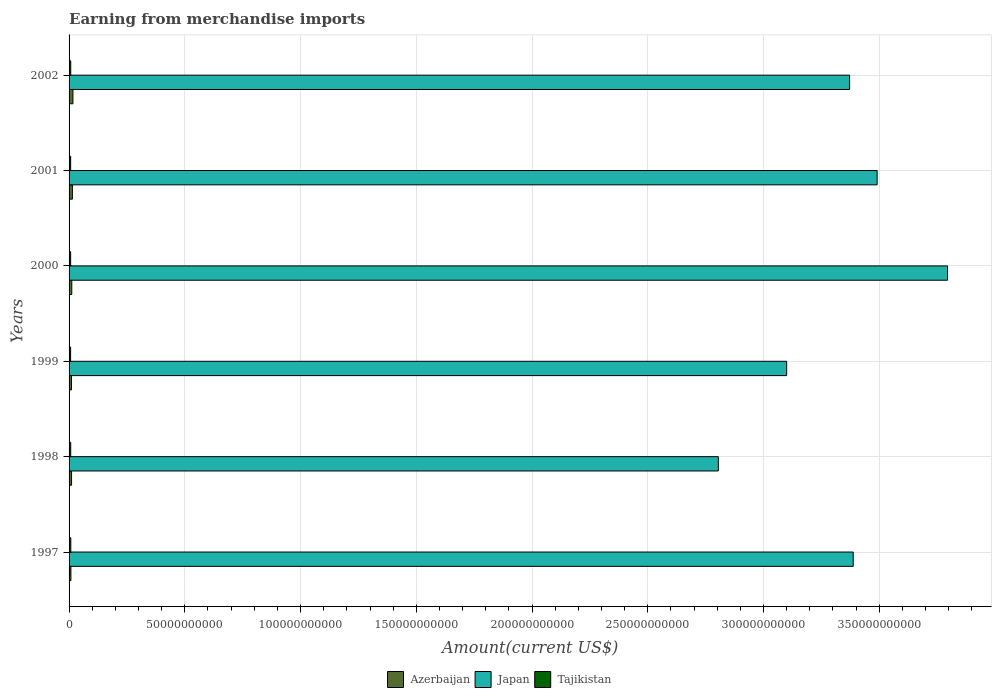How many bars are there on the 6th tick from the top?
Your answer should be very brief. 3. What is the amount earned from merchandise imports in Japan in 2001?
Offer a very short reply. 3.49e+11. Across all years, what is the maximum amount earned from merchandise imports in Azerbaijan?
Give a very brief answer. 1.67e+09. Across all years, what is the minimum amount earned from merchandise imports in Tajikistan?
Provide a short and direct response. 6.63e+08. In which year was the amount earned from merchandise imports in Japan maximum?
Provide a short and direct response. 2000. What is the total amount earned from merchandise imports in Tajikistan in the graph?
Provide a succinct answer. 4.21e+09. What is the difference between the amount earned from merchandise imports in Tajikistan in 1998 and that in 2002?
Offer a very short reply. -1.10e+07. What is the difference between the amount earned from merchandise imports in Tajikistan in 2000 and the amount earned from merchandise imports in Japan in 2001?
Your response must be concise. -3.48e+11. What is the average amount earned from merchandise imports in Azerbaijan per year?
Provide a succinct answer. 1.20e+09. In the year 2002, what is the difference between the amount earned from merchandise imports in Japan and amount earned from merchandise imports in Azerbaijan?
Your answer should be compact. 3.36e+11. In how many years, is the amount earned from merchandise imports in Tajikistan greater than 270000000000 US$?
Ensure brevity in your answer.  0. What is the ratio of the amount earned from merchandise imports in Azerbaijan in 1999 to that in 2001?
Ensure brevity in your answer.  0.72. Is the amount earned from merchandise imports in Japan in 1998 less than that in 2001?
Provide a succinct answer. Yes. Is the difference between the amount earned from merchandise imports in Japan in 1999 and 2000 greater than the difference between the amount earned from merchandise imports in Azerbaijan in 1999 and 2000?
Ensure brevity in your answer.  No. What is the difference between the highest and the second highest amount earned from merchandise imports in Tajikistan?
Ensure brevity in your answer.  2.90e+07. What is the difference between the highest and the lowest amount earned from merchandise imports in Azerbaijan?
Provide a succinct answer. 8.72e+08. In how many years, is the amount earned from merchandise imports in Azerbaijan greater than the average amount earned from merchandise imports in Azerbaijan taken over all years?
Give a very brief answer. 2. What does the 3rd bar from the top in 1997 represents?
Make the answer very short. Azerbaijan. What does the 1st bar from the bottom in 1999 represents?
Offer a very short reply. Azerbaijan. Is it the case that in every year, the sum of the amount earned from merchandise imports in Japan and amount earned from merchandise imports in Azerbaijan is greater than the amount earned from merchandise imports in Tajikistan?
Your answer should be compact. Yes. How many years are there in the graph?
Keep it short and to the point. 6. Are the values on the major ticks of X-axis written in scientific E-notation?
Your response must be concise. No. Does the graph contain any zero values?
Your answer should be compact. No. Does the graph contain grids?
Offer a very short reply. Yes. How are the legend labels stacked?
Make the answer very short. Horizontal. What is the title of the graph?
Your answer should be compact. Earning from merchandise imports. What is the label or title of the X-axis?
Ensure brevity in your answer.  Amount(current US$). What is the label or title of the Y-axis?
Provide a short and direct response. Years. What is the Amount(current US$) of Azerbaijan in 1997?
Your response must be concise. 7.94e+08. What is the Amount(current US$) in Japan in 1997?
Your answer should be compact. 3.39e+11. What is the Amount(current US$) of Tajikistan in 1997?
Ensure brevity in your answer.  7.50e+08. What is the Amount(current US$) in Azerbaijan in 1998?
Offer a very short reply. 1.08e+09. What is the Amount(current US$) in Japan in 1998?
Offer a very short reply. 2.80e+11. What is the Amount(current US$) in Tajikistan in 1998?
Provide a short and direct response. 7.10e+08. What is the Amount(current US$) of Azerbaijan in 1999?
Offer a very short reply. 1.04e+09. What is the Amount(current US$) of Japan in 1999?
Provide a short and direct response. 3.10e+11. What is the Amount(current US$) of Tajikistan in 1999?
Keep it short and to the point. 6.63e+08. What is the Amount(current US$) of Azerbaijan in 2000?
Give a very brief answer. 1.17e+09. What is the Amount(current US$) in Japan in 2000?
Your answer should be very brief. 3.80e+11. What is the Amount(current US$) in Tajikistan in 2000?
Your response must be concise. 6.75e+08. What is the Amount(current US$) in Azerbaijan in 2001?
Provide a short and direct response. 1.43e+09. What is the Amount(current US$) in Japan in 2001?
Provide a succinct answer. 3.49e+11. What is the Amount(current US$) in Tajikistan in 2001?
Ensure brevity in your answer.  6.88e+08. What is the Amount(current US$) in Azerbaijan in 2002?
Offer a very short reply. 1.67e+09. What is the Amount(current US$) in Japan in 2002?
Offer a terse response. 3.37e+11. What is the Amount(current US$) in Tajikistan in 2002?
Give a very brief answer. 7.21e+08. Across all years, what is the maximum Amount(current US$) in Azerbaijan?
Give a very brief answer. 1.67e+09. Across all years, what is the maximum Amount(current US$) in Japan?
Offer a very short reply. 3.80e+11. Across all years, what is the maximum Amount(current US$) in Tajikistan?
Offer a terse response. 7.50e+08. Across all years, what is the minimum Amount(current US$) in Azerbaijan?
Ensure brevity in your answer.  7.94e+08. Across all years, what is the minimum Amount(current US$) in Japan?
Your answer should be compact. 2.80e+11. Across all years, what is the minimum Amount(current US$) of Tajikistan?
Ensure brevity in your answer.  6.63e+08. What is the total Amount(current US$) in Azerbaijan in the graph?
Your response must be concise. 7.17e+09. What is the total Amount(current US$) of Japan in the graph?
Your answer should be very brief. 2.00e+12. What is the total Amount(current US$) of Tajikistan in the graph?
Offer a terse response. 4.21e+09. What is the difference between the Amount(current US$) in Azerbaijan in 1997 and that in 1998?
Make the answer very short. -2.82e+08. What is the difference between the Amount(current US$) in Japan in 1997 and that in 1998?
Offer a very short reply. 5.83e+1. What is the difference between the Amount(current US$) of Tajikistan in 1997 and that in 1998?
Your answer should be very brief. 4.00e+07. What is the difference between the Amount(current US$) in Azerbaijan in 1997 and that in 1999?
Keep it short and to the point. -2.42e+08. What is the difference between the Amount(current US$) of Japan in 1997 and that in 1999?
Your answer should be compact. 2.88e+1. What is the difference between the Amount(current US$) of Tajikistan in 1997 and that in 1999?
Make the answer very short. 8.70e+07. What is the difference between the Amount(current US$) in Azerbaijan in 1997 and that in 2000?
Provide a short and direct response. -3.78e+08. What is the difference between the Amount(current US$) in Japan in 1997 and that in 2000?
Your answer should be compact. -4.08e+1. What is the difference between the Amount(current US$) of Tajikistan in 1997 and that in 2000?
Your answer should be compact. 7.50e+07. What is the difference between the Amount(current US$) in Azerbaijan in 1997 and that in 2001?
Your response must be concise. -6.37e+08. What is the difference between the Amount(current US$) in Japan in 1997 and that in 2001?
Offer a very short reply. -1.03e+1. What is the difference between the Amount(current US$) in Tajikistan in 1997 and that in 2001?
Your answer should be very brief. 6.20e+07. What is the difference between the Amount(current US$) of Azerbaijan in 1997 and that in 2002?
Give a very brief answer. -8.72e+08. What is the difference between the Amount(current US$) in Japan in 1997 and that in 2002?
Provide a short and direct response. 1.56e+09. What is the difference between the Amount(current US$) of Tajikistan in 1997 and that in 2002?
Provide a succinct answer. 2.90e+07. What is the difference between the Amount(current US$) of Azerbaijan in 1998 and that in 1999?
Offer a very short reply. 4.00e+07. What is the difference between the Amount(current US$) of Japan in 1998 and that in 1999?
Provide a short and direct response. -2.95e+1. What is the difference between the Amount(current US$) in Tajikistan in 1998 and that in 1999?
Give a very brief answer. 4.70e+07. What is the difference between the Amount(current US$) in Azerbaijan in 1998 and that in 2000?
Offer a terse response. -9.60e+07. What is the difference between the Amount(current US$) in Japan in 1998 and that in 2000?
Offer a very short reply. -9.90e+1. What is the difference between the Amount(current US$) of Tajikistan in 1998 and that in 2000?
Provide a succinct answer. 3.50e+07. What is the difference between the Amount(current US$) in Azerbaijan in 1998 and that in 2001?
Make the answer very short. -3.55e+08. What is the difference between the Amount(current US$) of Japan in 1998 and that in 2001?
Your response must be concise. -6.86e+1. What is the difference between the Amount(current US$) of Tajikistan in 1998 and that in 2001?
Your answer should be very brief. 2.20e+07. What is the difference between the Amount(current US$) in Azerbaijan in 1998 and that in 2002?
Offer a terse response. -5.90e+08. What is the difference between the Amount(current US$) in Japan in 1998 and that in 2002?
Provide a succinct answer. -5.67e+1. What is the difference between the Amount(current US$) in Tajikistan in 1998 and that in 2002?
Provide a succinct answer. -1.10e+07. What is the difference between the Amount(current US$) of Azerbaijan in 1999 and that in 2000?
Provide a succinct answer. -1.36e+08. What is the difference between the Amount(current US$) in Japan in 1999 and that in 2000?
Your response must be concise. -6.95e+1. What is the difference between the Amount(current US$) of Tajikistan in 1999 and that in 2000?
Provide a short and direct response. -1.20e+07. What is the difference between the Amount(current US$) of Azerbaijan in 1999 and that in 2001?
Offer a very short reply. -3.95e+08. What is the difference between the Amount(current US$) in Japan in 1999 and that in 2001?
Keep it short and to the point. -3.91e+1. What is the difference between the Amount(current US$) in Tajikistan in 1999 and that in 2001?
Give a very brief answer. -2.50e+07. What is the difference between the Amount(current US$) of Azerbaijan in 1999 and that in 2002?
Your answer should be compact. -6.30e+08. What is the difference between the Amount(current US$) of Japan in 1999 and that in 2002?
Keep it short and to the point. -2.72e+1. What is the difference between the Amount(current US$) in Tajikistan in 1999 and that in 2002?
Your answer should be very brief. -5.80e+07. What is the difference between the Amount(current US$) in Azerbaijan in 2000 and that in 2001?
Provide a short and direct response. -2.59e+08. What is the difference between the Amount(current US$) of Japan in 2000 and that in 2001?
Provide a succinct answer. 3.04e+1. What is the difference between the Amount(current US$) of Tajikistan in 2000 and that in 2001?
Provide a short and direct response. -1.30e+07. What is the difference between the Amount(current US$) in Azerbaijan in 2000 and that in 2002?
Make the answer very short. -4.94e+08. What is the difference between the Amount(current US$) in Japan in 2000 and that in 2002?
Keep it short and to the point. 4.23e+1. What is the difference between the Amount(current US$) of Tajikistan in 2000 and that in 2002?
Ensure brevity in your answer.  -4.60e+07. What is the difference between the Amount(current US$) in Azerbaijan in 2001 and that in 2002?
Your response must be concise. -2.34e+08. What is the difference between the Amount(current US$) in Japan in 2001 and that in 2002?
Ensure brevity in your answer.  1.19e+1. What is the difference between the Amount(current US$) in Tajikistan in 2001 and that in 2002?
Keep it short and to the point. -3.30e+07. What is the difference between the Amount(current US$) of Azerbaijan in 1997 and the Amount(current US$) of Japan in 1998?
Make the answer very short. -2.80e+11. What is the difference between the Amount(current US$) of Azerbaijan in 1997 and the Amount(current US$) of Tajikistan in 1998?
Keep it short and to the point. 8.40e+07. What is the difference between the Amount(current US$) of Japan in 1997 and the Amount(current US$) of Tajikistan in 1998?
Provide a short and direct response. 3.38e+11. What is the difference between the Amount(current US$) of Azerbaijan in 1997 and the Amount(current US$) of Japan in 1999?
Your response must be concise. -3.09e+11. What is the difference between the Amount(current US$) in Azerbaijan in 1997 and the Amount(current US$) in Tajikistan in 1999?
Keep it short and to the point. 1.31e+08. What is the difference between the Amount(current US$) of Japan in 1997 and the Amount(current US$) of Tajikistan in 1999?
Keep it short and to the point. 3.38e+11. What is the difference between the Amount(current US$) in Azerbaijan in 1997 and the Amount(current US$) in Japan in 2000?
Offer a very short reply. -3.79e+11. What is the difference between the Amount(current US$) of Azerbaijan in 1997 and the Amount(current US$) of Tajikistan in 2000?
Offer a terse response. 1.19e+08. What is the difference between the Amount(current US$) of Japan in 1997 and the Amount(current US$) of Tajikistan in 2000?
Offer a terse response. 3.38e+11. What is the difference between the Amount(current US$) in Azerbaijan in 1997 and the Amount(current US$) in Japan in 2001?
Provide a succinct answer. -3.48e+11. What is the difference between the Amount(current US$) of Azerbaijan in 1997 and the Amount(current US$) of Tajikistan in 2001?
Provide a succinct answer. 1.06e+08. What is the difference between the Amount(current US$) in Japan in 1997 and the Amount(current US$) in Tajikistan in 2001?
Offer a very short reply. 3.38e+11. What is the difference between the Amount(current US$) in Azerbaijan in 1997 and the Amount(current US$) in Japan in 2002?
Ensure brevity in your answer.  -3.36e+11. What is the difference between the Amount(current US$) in Azerbaijan in 1997 and the Amount(current US$) in Tajikistan in 2002?
Your response must be concise. 7.30e+07. What is the difference between the Amount(current US$) in Japan in 1997 and the Amount(current US$) in Tajikistan in 2002?
Provide a short and direct response. 3.38e+11. What is the difference between the Amount(current US$) in Azerbaijan in 1998 and the Amount(current US$) in Japan in 1999?
Provide a succinct answer. -3.09e+11. What is the difference between the Amount(current US$) in Azerbaijan in 1998 and the Amount(current US$) in Tajikistan in 1999?
Your answer should be compact. 4.13e+08. What is the difference between the Amount(current US$) of Japan in 1998 and the Amount(current US$) of Tajikistan in 1999?
Offer a very short reply. 2.80e+11. What is the difference between the Amount(current US$) in Azerbaijan in 1998 and the Amount(current US$) in Japan in 2000?
Provide a short and direct response. -3.78e+11. What is the difference between the Amount(current US$) of Azerbaijan in 1998 and the Amount(current US$) of Tajikistan in 2000?
Give a very brief answer. 4.01e+08. What is the difference between the Amount(current US$) in Japan in 1998 and the Amount(current US$) in Tajikistan in 2000?
Keep it short and to the point. 2.80e+11. What is the difference between the Amount(current US$) of Azerbaijan in 1998 and the Amount(current US$) of Japan in 2001?
Offer a terse response. -3.48e+11. What is the difference between the Amount(current US$) of Azerbaijan in 1998 and the Amount(current US$) of Tajikistan in 2001?
Ensure brevity in your answer.  3.88e+08. What is the difference between the Amount(current US$) of Japan in 1998 and the Amount(current US$) of Tajikistan in 2001?
Make the answer very short. 2.80e+11. What is the difference between the Amount(current US$) of Azerbaijan in 1998 and the Amount(current US$) of Japan in 2002?
Your answer should be compact. -3.36e+11. What is the difference between the Amount(current US$) in Azerbaijan in 1998 and the Amount(current US$) in Tajikistan in 2002?
Provide a succinct answer. 3.55e+08. What is the difference between the Amount(current US$) of Japan in 1998 and the Amount(current US$) of Tajikistan in 2002?
Provide a short and direct response. 2.80e+11. What is the difference between the Amount(current US$) in Azerbaijan in 1999 and the Amount(current US$) in Japan in 2000?
Your answer should be compact. -3.78e+11. What is the difference between the Amount(current US$) of Azerbaijan in 1999 and the Amount(current US$) of Tajikistan in 2000?
Offer a terse response. 3.61e+08. What is the difference between the Amount(current US$) of Japan in 1999 and the Amount(current US$) of Tajikistan in 2000?
Make the answer very short. 3.09e+11. What is the difference between the Amount(current US$) of Azerbaijan in 1999 and the Amount(current US$) of Japan in 2001?
Offer a terse response. -3.48e+11. What is the difference between the Amount(current US$) of Azerbaijan in 1999 and the Amount(current US$) of Tajikistan in 2001?
Offer a very short reply. 3.48e+08. What is the difference between the Amount(current US$) of Japan in 1999 and the Amount(current US$) of Tajikistan in 2001?
Make the answer very short. 3.09e+11. What is the difference between the Amount(current US$) of Azerbaijan in 1999 and the Amount(current US$) of Japan in 2002?
Your answer should be compact. -3.36e+11. What is the difference between the Amount(current US$) in Azerbaijan in 1999 and the Amount(current US$) in Tajikistan in 2002?
Your answer should be very brief. 3.15e+08. What is the difference between the Amount(current US$) of Japan in 1999 and the Amount(current US$) of Tajikistan in 2002?
Make the answer very short. 3.09e+11. What is the difference between the Amount(current US$) in Azerbaijan in 2000 and the Amount(current US$) in Japan in 2001?
Ensure brevity in your answer.  -3.48e+11. What is the difference between the Amount(current US$) in Azerbaijan in 2000 and the Amount(current US$) in Tajikistan in 2001?
Make the answer very short. 4.84e+08. What is the difference between the Amount(current US$) of Japan in 2000 and the Amount(current US$) of Tajikistan in 2001?
Give a very brief answer. 3.79e+11. What is the difference between the Amount(current US$) in Azerbaijan in 2000 and the Amount(current US$) in Japan in 2002?
Provide a short and direct response. -3.36e+11. What is the difference between the Amount(current US$) in Azerbaijan in 2000 and the Amount(current US$) in Tajikistan in 2002?
Your response must be concise. 4.51e+08. What is the difference between the Amount(current US$) in Japan in 2000 and the Amount(current US$) in Tajikistan in 2002?
Your answer should be compact. 3.79e+11. What is the difference between the Amount(current US$) in Azerbaijan in 2001 and the Amount(current US$) in Japan in 2002?
Ensure brevity in your answer.  -3.36e+11. What is the difference between the Amount(current US$) of Azerbaijan in 2001 and the Amount(current US$) of Tajikistan in 2002?
Make the answer very short. 7.10e+08. What is the difference between the Amount(current US$) of Japan in 2001 and the Amount(current US$) of Tajikistan in 2002?
Your response must be concise. 3.48e+11. What is the average Amount(current US$) in Azerbaijan per year?
Provide a succinct answer. 1.20e+09. What is the average Amount(current US$) in Japan per year?
Your response must be concise. 3.33e+11. What is the average Amount(current US$) of Tajikistan per year?
Make the answer very short. 7.01e+08. In the year 1997, what is the difference between the Amount(current US$) of Azerbaijan and Amount(current US$) of Japan?
Provide a short and direct response. -3.38e+11. In the year 1997, what is the difference between the Amount(current US$) of Azerbaijan and Amount(current US$) of Tajikistan?
Make the answer very short. 4.40e+07. In the year 1997, what is the difference between the Amount(current US$) in Japan and Amount(current US$) in Tajikistan?
Provide a short and direct response. 3.38e+11. In the year 1998, what is the difference between the Amount(current US$) of Azerbaijan and Amount(current US$) of Japan?
Your answer should be compact. -2.79e+11. In the year 1998, what is the difference between the Amount(current US$) in Azerbaijan and Amount(current US$) in Tajikistan?
Keep it short and to the point. 3.66e+08. In the year 1998, what is the difference between the Amount(current US$) in Japan and Amount(current US$) in Tajikistan?
Your answer should be very brief. 2.80e+11. In the year 1999, what is the difference between the Amount(current US$) of Azerbaijan and Amount(current US$) of Japan?
Provide a succinct answer. -3.09e+11. In the year 1999, what is the difference between the Amount(current US$) of Azerbaijan and Amount(current US$) of Tajikistan?
Give a very brief answer. 3.73e+08. In the year 1999, what is the difference between the Amount(current US$) of Japan and Amount(current US$) of Tajikistan?
Your answer should be compact. 3.09e+11. In the year 2000, what is the difference between the Amount(current US$) in Azerbaijan and Amount(current US$) in Japan?
Offer a terse response. -3.78e+11. In the year 2000, what is the difference between the Amount(current US$) in Azerbaijan and Amount(current US$) in Tajikistan?
Make the answer very short. 4.97e+08. In the year 2000, what is the difference between the Amount(current US$) of Japan and Amount(current US$) of Tajikistan?
Keep it short and to the point. 3.79e+11. In the year 2001, what is the difference between the Amount(current US$) in Azerbaijan and Amount(current US$) in Japan?
Your answer should be compact. -3.48e+11. In the year 2001, what is the difference between the Amount(current US$) in Azerbaijan and Amount(current US$) in Tajikistan?
Ensure brevity in your answer.  7.43e+08. In the year 2001, what is the difference between the Amount(current US$) of Japan and Amount(current US$) of Tajikistan?
Offer a very short reply. 3.48e+11. In the year 2002, what is the difference between the Amount(current US$) of Azerbaijan and Amount(current US$) of Japan?
Your answer should be very brief. -3.36e+11. In the year 2002, what is the difference between the Amount(current US$) in Azerbaijan and Amount(current US$) in Tajikistan?
Give a very brief answer. 9.44e+08. In the year 2002, what is the difference between the Amount(current US$) of Japan and Amount(current US$) of Tajikistan?
Give a very brief answer. 3.36e+11. What is the ratio of the Amount(current US$) in Azerbaijan in 1997 to that in 1998?
Offer a very short reply. 0.74. What is the ratio of the Amount(current US$) in Japan in 1997 to that in 1998?
Give a very brief answer. 1.21. What is the ratio of the Amount(current US$) of Tajikistan in 1997 to that in 1998?
Offer a very short reply. 1.06. What is the ratio of the Amount(current US$) of Azerbaijan in 1997 to that in 1999?
Offer a terse response. 0.77. What is the ratio of the Amount(current US$) in Japan in 1997 to that in 1999?
Your answer should be compact. 1.09. What is the ratio of the Amount(current US$) in Tajikistan in 1997 to that in 1999?
Offer a terse response. 1.13. What is the ratio of the Amount(current US$) in Azerbaijan in 1997 to that in 2000?
Ensure brevity in your answer.  0.68. What is the ratio of the Amount(current US$) in Japan in 1997 to that in 2000?
Give a very brief answer. 0.89. What is the ratio of the Amount(current US$) in Tajikistan in 1997 to that in 2000?
Keep it short and to the point. 1.11. What is the ratio of the Amount(current US$) in Azerbaijan in 1997 to that in 2001?
Offer a terse response. 0.55. What is the ratio of the Amount(current US$) of Japan in 1997 to that in 2001?
Your answer should be very brief. 0.97. What is the ratio of the Amount(current US$) in Tajikistan in 1997 to that in 2001?
Offer a terse response. 1.09. What is the ratio of the Amount(current US$) of Azerbaijan in 1997 to that in 2002?
Your response must be concise. 0.48. What is the ratio of the Amount(current US$) of Japan in 1997 to that in 2002?
Your response must be concise. 1. What is the ratio of the Amount(current US$) of Tajikistan in 1997 to that in 2002?
Your answer should be very brief. 1.04. What is the ratio of the Amount(current US$) in Azerbaijan in 1998 to that in 1999?
Offer a terse response. 1.04. What is the ratio of the Amount(current US$) in Japan in 1998 to that in 1999?
Give a very brief answer. 0.9. What is the ratio of the Amount(current US$) in Tajikistan in 1998 to that in 1999?
Provide a short and direct response. 1.07. What is the ratio of the Amount(current US$) in Azerbaijan in 1998 to that in 2000?
Provide a succinct answer. 0.92. What is the ratio of the Amount(current US$) of Japan in 1998 to that in 2000?
Provide a short and direct response. 0.74. What is the ratio of the Amount(current US$) of Tajikistan in 1998 to that in 2000?
Ensure brevity in your answer.  1.05. What is the ratio of the Amount(current US$) in Azerbaijan in 1998 to that in 2001?
Keep it short and to the point. 0.75. What is the ratio of the Amount(current US$) of Japan in 1998 to that in 2001?
Keep it short and to the point. 0.8. What is the ratio of the Amount(current US$) in Tajikistan in 1998 to that in 2001?
Give a very brief answer. 1.03. What is the ratio of the Amount(current US$) in Azerbaijan in 1998 to that in 2002?
Your answer should be very brief. 0.65. What is the ratio of the Amount(current US$) of Japan in 1998 to that in 2002?
Keep it short and to the point. 0.83. What is the ratio of the Amount(current US$) in Tajikistan in 1998 to that in 2002?
Give a very brief answer. 0.98. What is the ratio of the Amount(current US$) of Azerbaijan in 1999 to that in 2000?
Offer a very short reply. 0.88. What is the ratio of the Amount(current US$) of Japan in 1999 to that in 2000?
Make the answer very short. 0.82. What is the ratio of the Amount(current US$) in Tajikistan in 1999 to that in 2000?
Your answer should be very brief. 0.98. What is the ratio of the Amount(current US$) in Azerbaijan in 1999 to that in 2001?
Offer a terse response. 0.72. What is the ratio of the Amount(current US$) in Japan in 1999 to that in 2001?
Give a very brief answer. 0.89. What is the ratio of the Amount(current US$) in Tajikistan in 1999 to that in 2001?
Your answer should be very brief. 0.96. What is the ratio of the Amount(current US$) of Azerbaijan in 1999 to that in 2002?
Your answer should be very brief. 0.62. What is the ratio of the Amount(current US$) in Japan in 1999 to that in 2002?
Offer a terse response. 0.92. What is the ratio of the Amount(current US$) in Tajikistan in 1999 to that in 2002?
Your response must be concise. 0.92. What is the ratio of the Amount(current US$) in Azerbaijan in 2000 to that in 2001?
Make the answer very short. 0.82. What is the ratio of the Amount(current US$) of Japan in 2000 to that in 2001?
Make the answer very short. 1.09. What is the ratio of the Amount(current US$) of Tajikistan in 2000 to that in 2001?
Your response must be concise. 0.98. What is the ratio of the Amount(current US$) of Azerbaijan in 2000 to that in 2002?
Provide a succinct answer. 0.7. What is the ratio of the Amount(current US$) of Japan in 2000 to that in 2002?
Ensure brevity in your answer.  1.13. What is the ratio of the Amount(current US$) in Tajikistan in 2000 to that in 2002?
Make the answer very short. 0.94. What is the ratio of the Amount(current US$) of Azerbaijan in 2001 to that in 2002?
Keep it short and to the point. 0.86. What is the ratio of the Amount(current US$) of Japan in 2001 to that in 2002?
Your response must be concise. 1.04. What is the ratio of the Amount(current US$) in Tajikistan in 2001 to that in 2002?
Provide a short and direct response. 0.95. What is the difference between the highest and the second highest Amount(current US$) in Azerbaijan?
Make the answer very short. 2.34e+08. What is the difference between the highest and the second highest Amount(current US$) of Japan?
Offer a terse response. 3.04e+1. What is the difference between the highest and the second highest Amount(current US$) of Tajikistan?
Provide a succinct answer. 2.90e+07. What is the difference between the highest and the lowest Amount(current US$) in Azerbaijan?
Offer a very short reply. 8.72e+08. What is the difference between the highest and the lowest Amount(current US$) of Japan?
Offer a very short reply. 9.90e+1. What is the difference between the highest and the lowest Amount(current US$) of Tajikistan?
Give a very brief answer. 8.70e+07. 